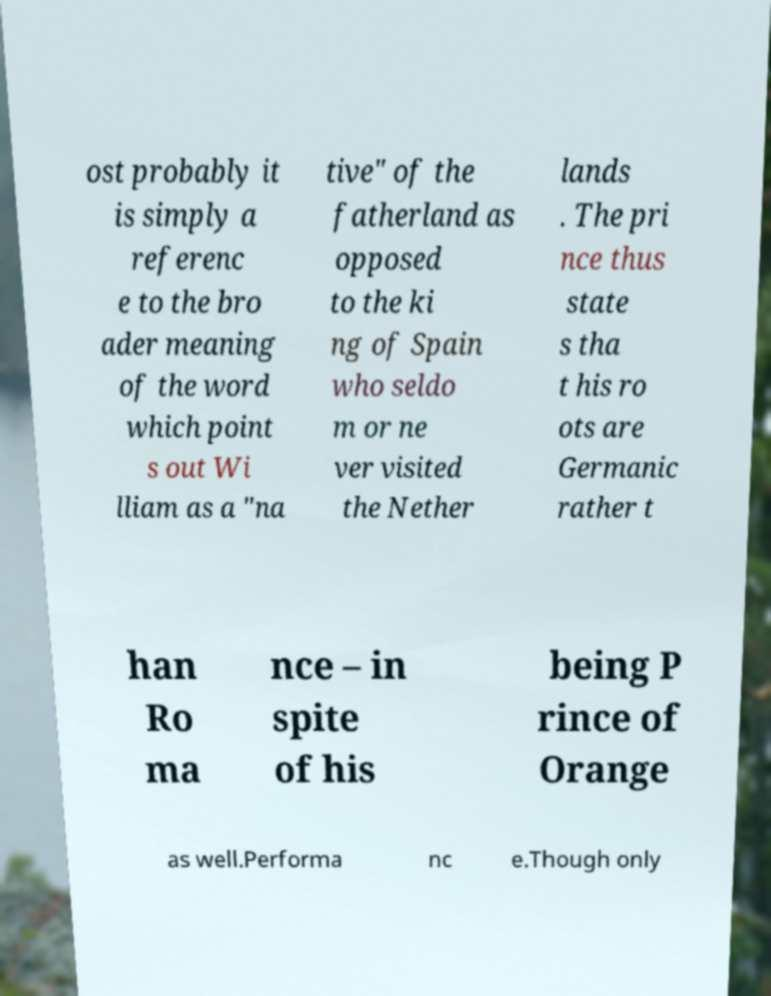Can you accurately transcribe the text from the provided image for me? ost probably it is simply a referenc e to the bro ader meaning of the word which point s out Wi lliam as a "na tive" of the fatherland as opposed to the ki ng of Spain who seldo m or ne ver visited the Nether lands . The pri nce thus state s tha t his ro ots are Germanic rather t han Ro ma nce – in spite of his being P rince of Orange as well.Performa nc e.Though only 